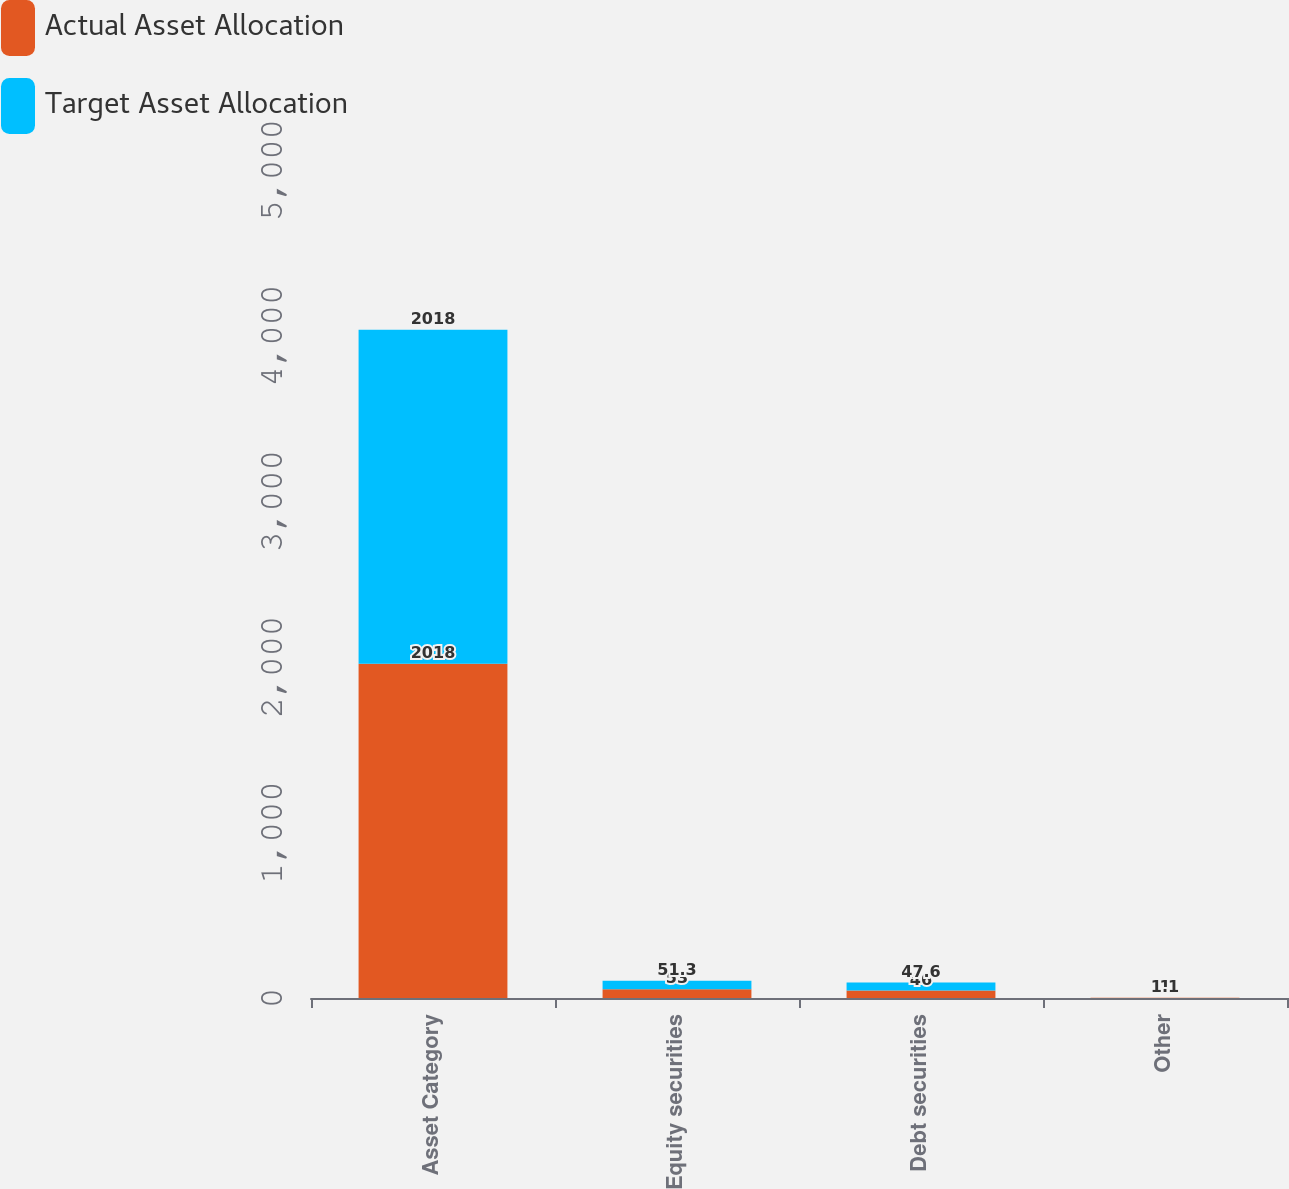<chart> <loc_0><loc_0><loc_500><loc_500><stacked_bar_chart><ecel><fcel>Asset Category<fcel>Equity securities<fcel>Debt securities<fcel>Other<nl><fcel>Actual Asset Allocation<fcel>2018<fcel>53<fcel>46<fcel>1<nl><fcel>Target Asset Allocation<fcel>2018<fcel>51.3<fcel>47.6<fcel>1.1<nl></chart> 